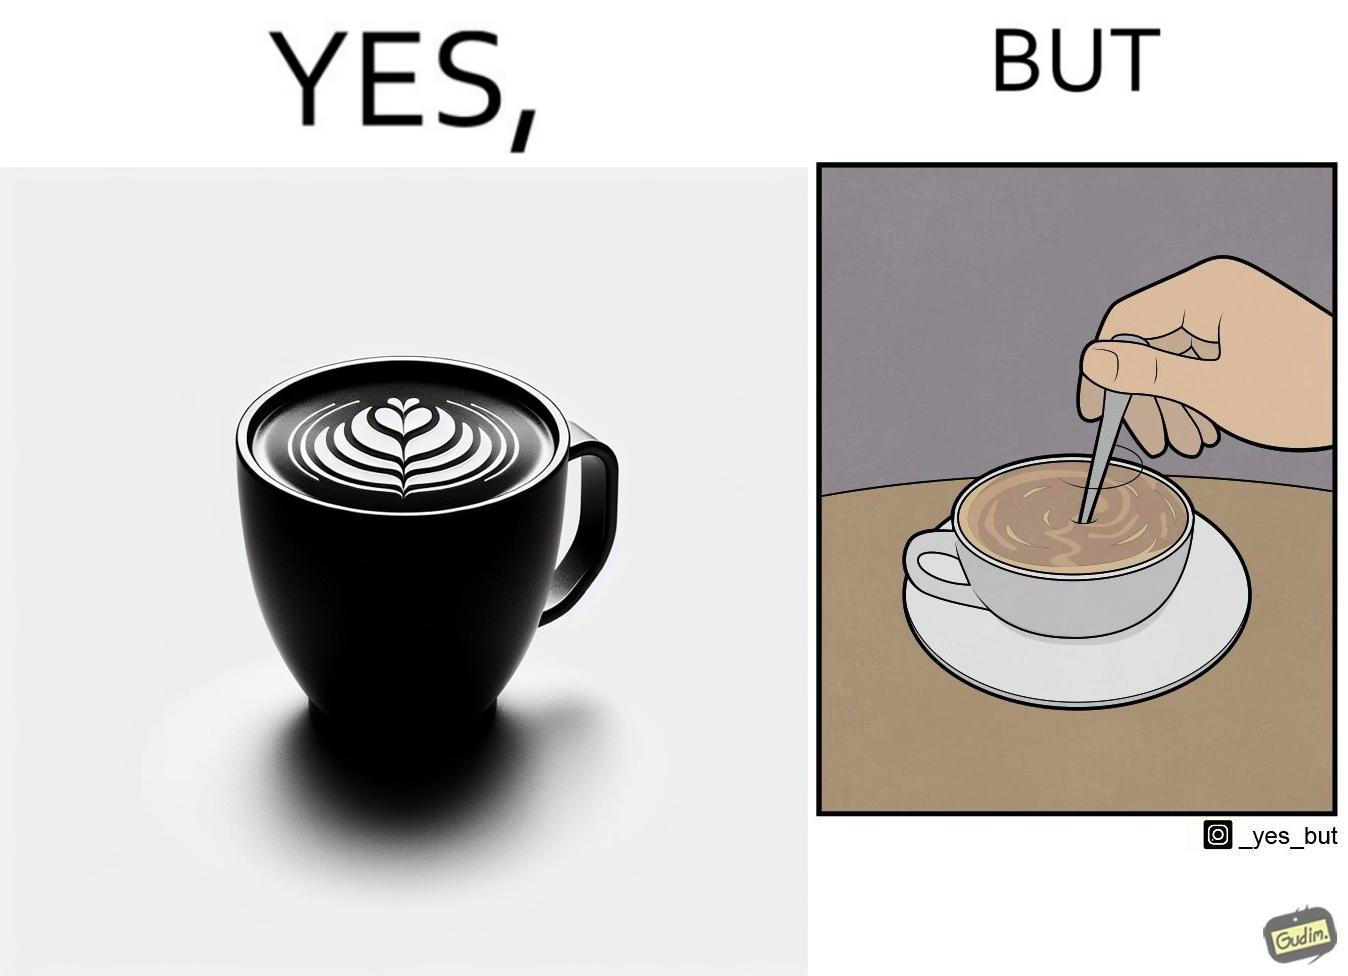Is there satirical content in this image? Yes, this image is satirical. 